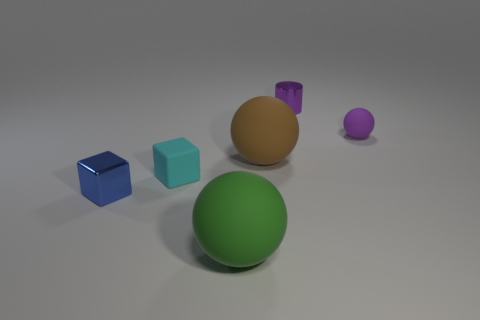Does the small object on the right side of the purple metal object have the same material as the large green sphere?
Your answer should be compact. Yes. Is there a cyan block behind the large thing to the right of the green object?
Keep it short and to the point. No. What is the material of the blue thing that is the same shape as the tiny cyan object?
Ensure brevity in your answer.  Metal. Is the number of tiny blue metallic things that are on the left side of the small blue object greater than the number of tiny things in front of the shiny cylinder?
Provide a succinct answer. No. The tiny purple thing that is the same material as the cyan thing is what shape?
Offer a very short reply. Sphere. Are there more brown rubber things in front of the small cyan matte cube than cyan rubber objects?
Give a very brief answer. No. What number of other matte spheres are the same color as the tiny sphere?
Your answer should be compact. 0. What number of other things are there of the same color as the cylinder?
Give a very brief answer. 1. Is the number of purple spheres greater than the number of yellow metal cylinders?
Offer a very short reply. Yes. What is the material of the purple cylinder?
Give a very brief answer. Metal. 